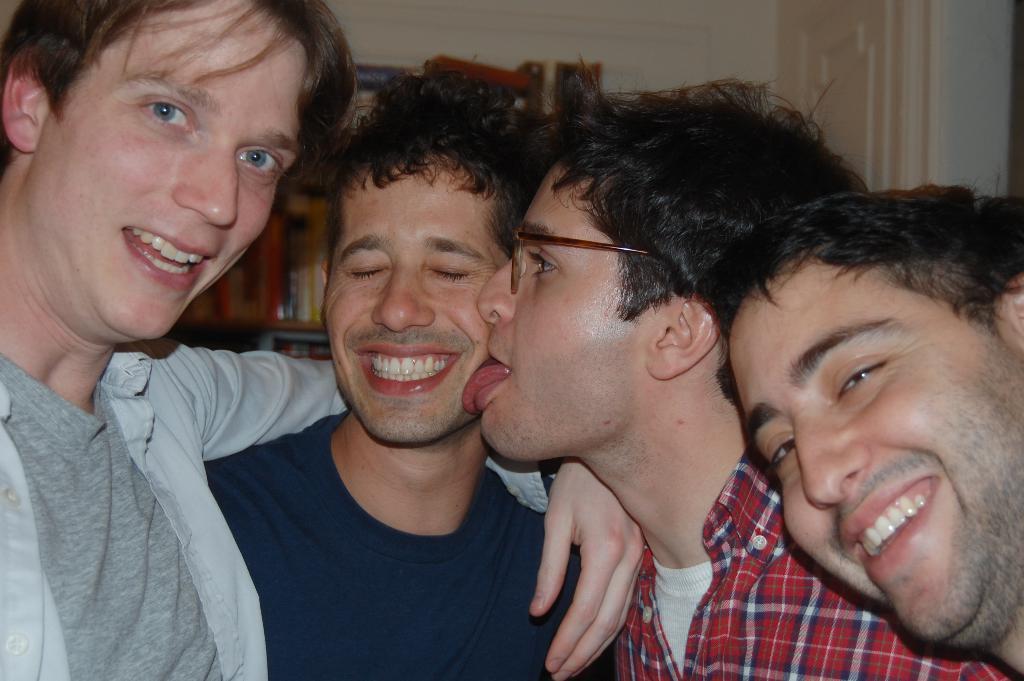In one or two sentences, can you explain what this image depicts? In this image we can see few people, in the background there is a shelf with books on the shelf and there is a door and wall. 